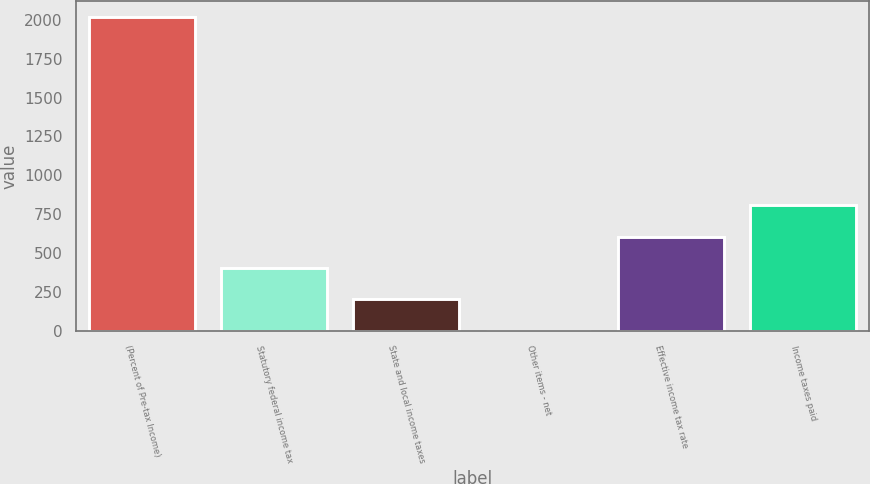Convert chart. <chart><loc_0><loc_0><loc_500><loc_500><bar_chart><fcel>(Percent of Pre-tax Income)<fcel>Statutory federal income tax<fcel>State and local income taxes<fcel>Other items - net<fcel>Effective income tax rate<fcel>Income taxes paid<nl><fcel>2018<fcel>404.64<fcel>202.97<fcel>1.3<fcel>606.31<fcel>807.98<nl></chart> 